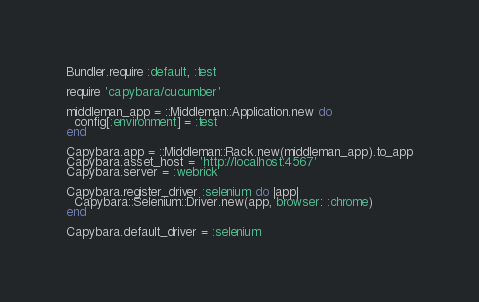<code> <loc_0><loc_0><loc_500><loc_500><_Ruby_>Bundler.require :default, :test

require 'capybara/cucumber'

middleman_app = ::Middleman::Application.new do
  config[:environment] = :test
end

Capybara.app = ::Middleman::Rack.new(middleman_app).to_app
Capybara.asset_host = 'http://localhost:4567'
Capybara.server = :webrick

Capybara.register_driver :selenium do |app|
  Capybara::Selenium::Driver.new(app, browser: :chrome)
end

Capybara.default_driver = :selenium
</code> 